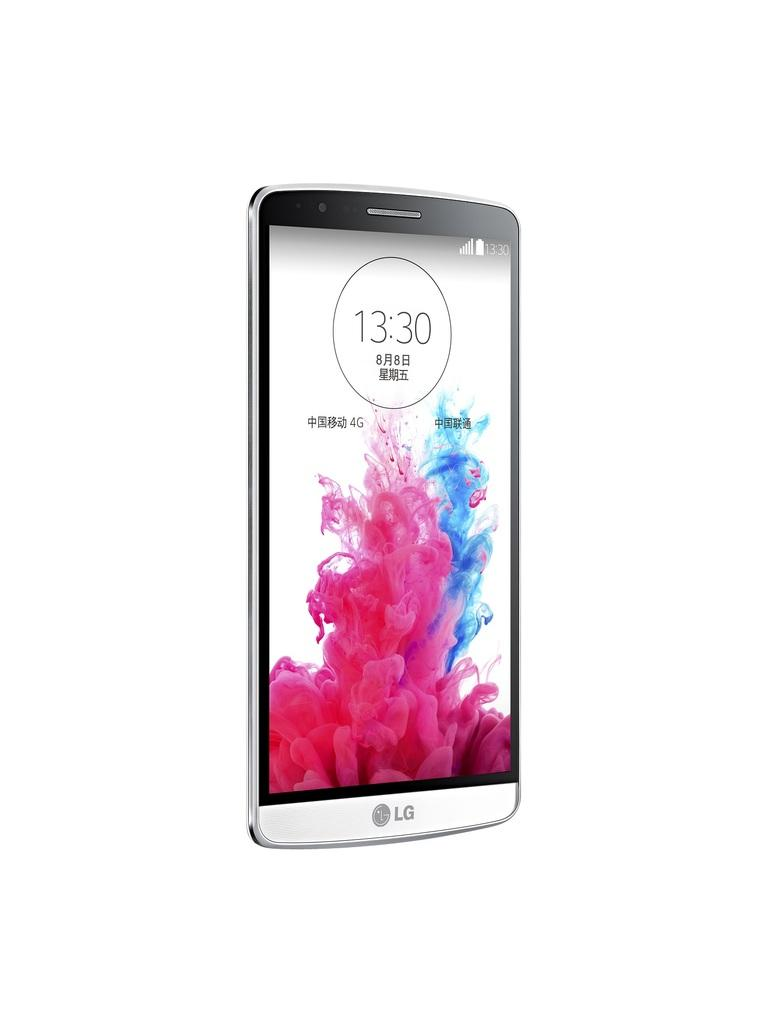Provide a one-sentence caption for the provided image. The time on the LG phone is 13:30. 